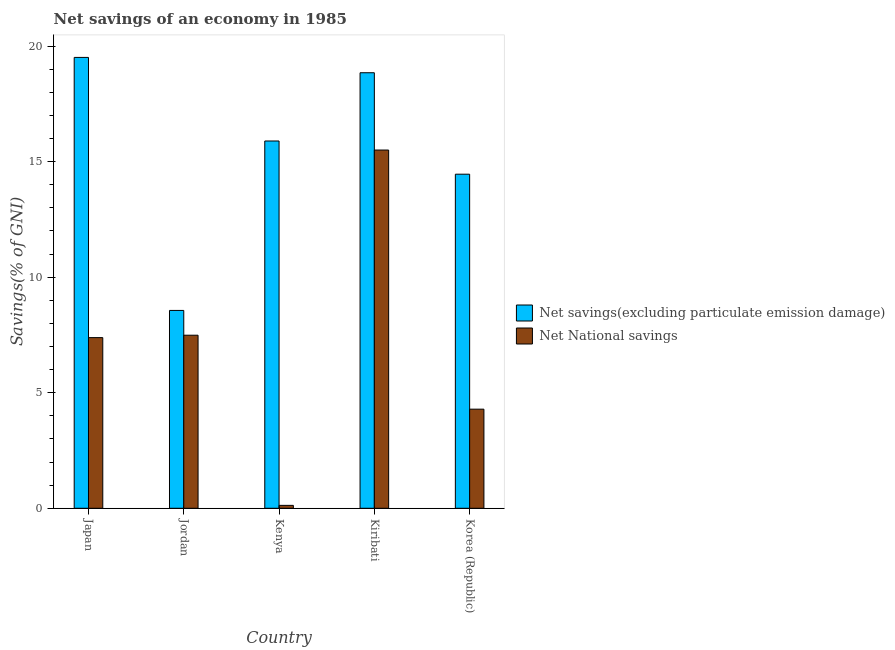How many groups of bars are there?
Make the answer very short. 5. Are the number of bars per tick equal to the number of legend labels?
Keep it short and to the point. Yes. Are the number of bars on each tick of the X-axis equal?
Ensure brevity in your answer.  Yes. How many bars are there on the 5th tick from the right?
Offer a terse response. 2. What is the label of the 4th group of bars from the left?
Ensure brevity in your answer.  Kiribati. In how many cases, is the number of bars for a given country not equal to the number of legend labels?
Ensure brevity in your answer.  0. What is the net national savings in Jordan?
Give a very brief answer. 7.49. Across all countries, what is the maximum net national savings?
Provide a succinct answer. 15.5. Across all countries, what is the minimum net savings(excluding particulate emission damage)?
Ensure brevity in your answer.  8.56. In which country was the net savings(excluding particulate emission damage) maximum?
Offer a terse response. Japan. In which country was the net savings(excluding particulate emission damage) minimum?
Ensure brevity in your answer.  Jordan. What is the total net savings(excluding particulate emission damage) in the graph?
Make the answer very short. 77.28. What is the difference between the net national savings in Jordan and that in Korea (Republic)?
Provide a short and direct response. 3.2. What is the difference between the net national savings in Kenya and the net savings(excluding particulate emission damage) in Jordan?
Ensure brevity in your answer.  -8.44. What is the average net national savings per country?
Give a very brief answer. 6.96. What is the difference between the net national savings and net savings(excluding particulate emission damage) in Jordan?
Your answer should be compact. -1.07. What is the ratio of the net savings(excluding particulate emission damage) in Jordan to that in Korea (Republic)?
Give a very brief answer. 0.59. Is the net national savings in Japan less than that in Kiribati?
Your answer should be compact. Yes. What is the difference between the highest and the second highest net savings(excluding particulate emission damage)?
Provide a short and direct response. 0.66. What is the difference between the highest and the lowest net national savings?
Offer a terse response. 15.38. In how many countries, is the net national savings greater than the average net national savings taken over all countries?
Provide a short and direct response. 3. What does the 2nd bar from the left in Kenya represents?
Keep it short and to the point. Net National savings. What does the 1st bar from the right in Kenya represents?
Offer a very short reply. Net National savings. How many bars are there?
Make the answer very short. 10. Are all the bars in the graph horizontal?
Provide a short and direct response. No. How many countries are there in the graph?
Offer a very short reply. 5. Are the values on the major ticks of Y-axis written in scientific E-notation?
Your answer should be very brief. No. Does the graph contain any zero values?
Your answer should be very brief. No. How many legend labels are there?
Offer a very short reply. 2. How are the legend labels stacked?
Offer a terse response. Vertical. What is the title of the graph?
Offer a very short reply. Net savings of an economy in 1985. What is the label or title of the X-axis?
Provide a succinct answer. Country. What is the label or title of the Y-axis?
Your answer should be compact. Savings(% of GNI). What is the Savings(% of GNI) in Net savings(excluding particulate emission damage) in Japan?
Make the answer very short. 19.51. What is the Savings(% of GNI) of Net National savings in Japan?
Offer a very short reply. 7.39. What is the Savings(% of GNI) in Net savings(excluding particulate emission damage) in Jordan?
Keep it short and to the point. 8.56. What is the Savings(% of GNI) in Net National savings in Jordan?
Keep it short and to the point. 7.49. What is the Savings(% of GNI) in Net savings(excluding particulate emission damage) in Kenya?
Offer a terse response. 15.89. What is the Savings(% of GNI) in Net National savings in Kenya?
Make the answer very short. 0.13. What is the Savings(% of GNI) of Net savings(excluding particulate emission damage) in Kiribati?
Keep it short and to the point. 18.85. What is the Savings(% of GNI) in Net National savings in Kiribati?
Ensure brevity in your answer.  15.5. What is the Savings(% of GNI) in Net savings(excluding particulate emission damage) in Korea (Republic)?
Offer a very short reply. 14.46. What is the Savings(% of GNI) of Net National savings in Korea (Republic)?
Offer a very short reply. 4.29. Across all countries, what is the maximum Savings(% of GNI) of Net savings(excluding particulate emission damage)?
Your answer should be very brief. 19.51. Across all countries, what is the maximum Savings(% of GNI) of Net National savings?
Provide a succinct answer. 15.5. Across all countries, what is the minimum Savings(% of GNI) in Net savings(excluding particulate emission damage)?
Ensure brevity in your answer.  8.56. Across all countries, what is the minimum Savings(% of GNI) in Net National savings?
Offer a terse response. 0.13. What is the total Savings(% of GNI) of Net savings(excluding particulate emission damage) in the graph?
Ensure brevity in your answer.  77.28. What is the total Savings(% of GNI) in Net National savings in the graph?
Provide a succinct answer. 34.79. What is the difference between the Savings(% of GNI) in Net savings(excluding particulate emission damage) in Japan and that in Jordan?
Provide a succinct answer. 10.95. What is the difference between the Savings(% of GNI) in Net National savings in Japan and that in Jordan?
Offer a terse response. -0.1. What is the difference between the Savings(% of GNI) of Net savings(excluding particulate emission damage) in Japan and that in Kenya?
Keep it short and to the point. 3.62. What is the difference between the Savings(% of GNI) of Net National savings in Japan and that in Kenya?
Ensure brevity in your answer.  7.26. What is the difference between the Savings(% of GNI) in Net savings(excluding particulate emission damage) in Japan and that in Kiribati?
Offer a terse response. 0.66. What is the difference between the Savings(% of GNI) in Net National savings in Japan and that in Kiribati?
Provide a succinct answer. -8.12. What is the difference between the Savings(% of GNI) of Net savings(excluding particulate emission damage) in Japan and that in Korea (Republic)?
Offer a terse response. 5.05. What is the difference between the Savings(% of GNI) in Net National savings in Japan and that in Korea (Republic)?
Ensure brevity in your answer.  3.1. What is the difference between the Savings(% of GNI) of Net savings(excluding particulate emission damage) in Jordan and that in Kenya?
Keep it short and to the point. -7.33. What is the difference between the Savings(% of GNI) in Net National savings in Jordan and that in Kenya?
Make the answer very short. 7.36. What is the difference between the Savings(% of GNI) of Net savings(excluding particulate emission damage) in Jordan and that in Kiribati?
Your response must be concise. -10.29. What is the difference between the Savings(% of GNI) in Net National savings in Jordan and that in Kiribati?
Give a very brief answer. -8.01. What is the difference between the Savings(% of GNI) in Net savings(excluding particulate emission damage) in Jordan and that in Korea (Republic)?
Provide a short and direct response. -5.9. What is the difference between the Savings(% of GNI) of Net National savings in Jordan and that in Korea (Republic)?
Offer a terse response. 3.2. What is the difference between the Savings(% of GNI) of Net savings(excluding particulate emission damage) in Kenya and that in Kiribati?
Your response must be concise. -2.95. What is the difference between the Savings(% of GNI) in Net National savings in Kenya and that in Kiribati?
Offer a very short reply. -15.38. What is the difference between the Savings(% of GNI) in Net savings(excluding particulate emission damage) in Kenya and that in Korea (Republic)?
Make the answer very short. 1.44. What is the difference between the Savings(% of GNI) in Net National savings in Kenya and that in Korea (Republic)?
Offer a very short reply. -4.16. What is the difference between the Savings(% of GNI) of Net savings(excluding particulate emission damage) in Kiribati and that in Korea (Republic)?
Offer a very short reply. 4.39. What is the difference between the Savings(% of GNI) of Net National savings in Kiribati and that in Korea (Republic)?
Your answer should be very brief. 11.21. What is the difference between the Savings(% of GNI) of Net savings(excluding particulate emission damage) in Japan and the Savings(% of GNI) of Net National savings in Jordan?
Offer a very short reply. 12.02. What is the difference between the Savings(% of GNI) of Net savings(excluding particulate emission damage) in Japan and the Savings(% of GNI) of Net National savings in Kenya?
Give a very brief answer. 19.39. What is the difference between the Savings(% of GNI) of Net savings(excluding particulate emission damage) in Japan and the Savings(% of GNI) of Net National savings in Kiribati?
Ensure brevity in your answer.  4.01. What is the difference between the Savings(% of GNI) in Net savings(excluding particulate emission damage) in Japan and the Savings(% of GNI) in Net National savings in Korea (Republic)?
Your response must be concise. 15.22. What is the difference between the Savings(% of GNI) of Net savings(excluding particulate emission damage) in Jordan and the Savings(% of GNI) of Net National savings in Kenya?
Keep it short and to the point. 8.44. What is the difference between the Savings(% of GNI) in Net savings(excluding particulate emission damage) in Jordan and the Savings(% of GNI) in Net National savings in Kiribati?
Offer a very short reply. -6.94. What is the difference between the Savings(% of GNI) of Net savings(excluding particulate emission damage) in Jordan and the Savings(% of GNI) of Net National savings in Korea (Republic)?
Keep it short and to the point. 4.27. What is the difference between the Savings(% of GNI) of Net savings(excluding particulate emission damage) in Kenya and the Savings(% of GNI) of Net National savings in Kiribati?
Offer a very short reply. 0.39. What is the difference between the Savings(% of GNI) of Net savings(excluding particulate emission damage) in Kenya and the Savings(% of GNI) of Net National savings in Korea (Republic)?
Ensure brevity in your answer.  11.61. What is the difference between the Savings(% of GNI) of Net savings(excluding particulate emission damage) in Kiribati and the Savings(% of GNI) of Net National savings in Korea (Republic)?
Offer a terse response. 14.56. What is the average Savings(% of GNI) of Net savings(excluding particulate emission damage) per country?
Make the answer very short. 15.46. What is the average Savings(% of GNI) in Net National savings per country?
Ensure brevity in your answer.  6.96. What is the difference between the Savings(% of GNI) of Net savings(excluding particulate emission damage) and Savings(% of GNI) of Net National savings in Japan?
Offer a terse response. 12.13. What is the difference between the Savings(% of GNI) of Net savings(excluding particulate emission damage) and Savings(% of GNI) of Net National savings in Jordan?
Keep it short and to the point. 1.07. What is the difference between the Savings(% of GNI) in Net savings(excluding particulate emission damage) and Savings(% of GNI) in Net National savings in Kenya?
Keep it short and to the point. 15.77. What is the difference between the Savings(% of GNI) in Net savings(excluding particulate emission damage) and Savings(% of GNI) in Net National savings in Kiribati?
Keep it short and to the point. 3.35. What is the difference between the Savings(% of GNI) in Net savings(excluding particulate emission damage) and Savings(% of GNI) in Net National savings in Korea (Republic)?
Ensure brevity in your answer.  10.17. What is the ratio of the Savings(% of GNI) of Net savings(excluding particulate emission damage) in Japan to that in Jordan?
Offer a terse response. 2.28. What is the ratio of the Savings(% of GNI) of Net National savings in Japan to that in Jordan?
Make the answer very short. 0.99. What is the ratio of the Savings(% of GNI) of Net savings(excluding particulate emission damage) in Japan to that in Kenya?
Keep it short and to the point. 1.23. What is the ratio of the Savings(% of GNI) in Net National savings in Japan to that in Kenya?
Offer a terse response. 58.83. What is the ratio of the Savings(% of GNI) of Net savings(excluding particulate emission damage) in Japan to that in Kiribati?
Offer a very short reply. 1.04. What is the ratio of the Savings(% of GNI) of Net National savings in Japan to that in Kiribati?
Provide a succinct answer. 0.48. What is the ratio of the Savings(% of GNI) of Net savings(excluding particulate emission damage) in Japan to that in Korea (Republic)?
Keep it short and to the point. 1.35. What is the ratio of the Savings(% of GNI) of Net National savings in Japan to that in Korea (Republic)?
Make the answer very short. 1.72. What is the ratio of the Savings(% of GNI) of Net savings(excluding particulate emission damage) in Jordan to that in Kenya?
Provide a short and direct response. 0.54. What is the ratio of the Savings(% of GNI) of Net National savings in Jordan to that in Kenya?
Your response must be concise. 59.66. What is the ratio of the Savings(% of GNI) of Net savings(excluding particulate emission damage) in Jordan to that in Kiribati?
Provide a short and direct response. 0.45. What is the ratio of the Savings(% of GNI) of Net National savings in Jordan to that in Kiribati?
Ensure brevity in your answer.  0.48. What is the ratio of the Savings(% of GNI) of Net savings(excluding particulate emission damage) in Jordan to that in Korea (Republic)?
Your response must be concise. 0.59. What is the ratio of the Savings(% of GNI) of Net National savings in Jordan to that in Korea (Republic)?
Make the answer very short. 1.75. What is the ratio of the Savings(% of GNI) of Net savings(excluding particulate emission damage) in Kenya to that in Kiribati?
Provide a succinct answer. 0.84. What is the ratio of the Savings(% of GNI) of Net National savings in Kenya to that in Kiribati?
Your answer should be compact. 0.01. What is the ratio of the Savings(% of GNI) of Net savings(excluding particulate emission damage) in Kenya to that in Korea (Republic)?
Ensure brevity in your answer.  1.1. What is the ratio of the Savings(% of GNI) in Net National savings in Kenya to that in Korea (Republic)?
Give a very brief answer. 0.03. What is the ratio of the Savings(% of GNI) in Net savings(excluding particulate emission damage) in Kiribati to that in Korea (Republic)?
Ensure brevity in your answer.  1.3. What is the ratio of the Savings(% of GNI) of Net National savings in Kiribati to that in Korea (Republic)?
Keep it short and to the point. 3.61. What is the difference between the highest and the second highest Savings(% of GNI) in Net savings(excluding particulate emission damage)?
Your answer should be very brief. 0.66. What is the difference between the highest and the second highest Savings(% of GNI) in Net National savings?
Offer a terse response. 8.01. What is the difference between the highest and the lowest Savings(% of GNI) in Net savings(excluding particulate emission damage)?
Give a very brief answer. 10.95. What is the difference between the highest and the lowest Savings(% of GNI) in Net National savings?
Provide a short and direct response. 15.38. 